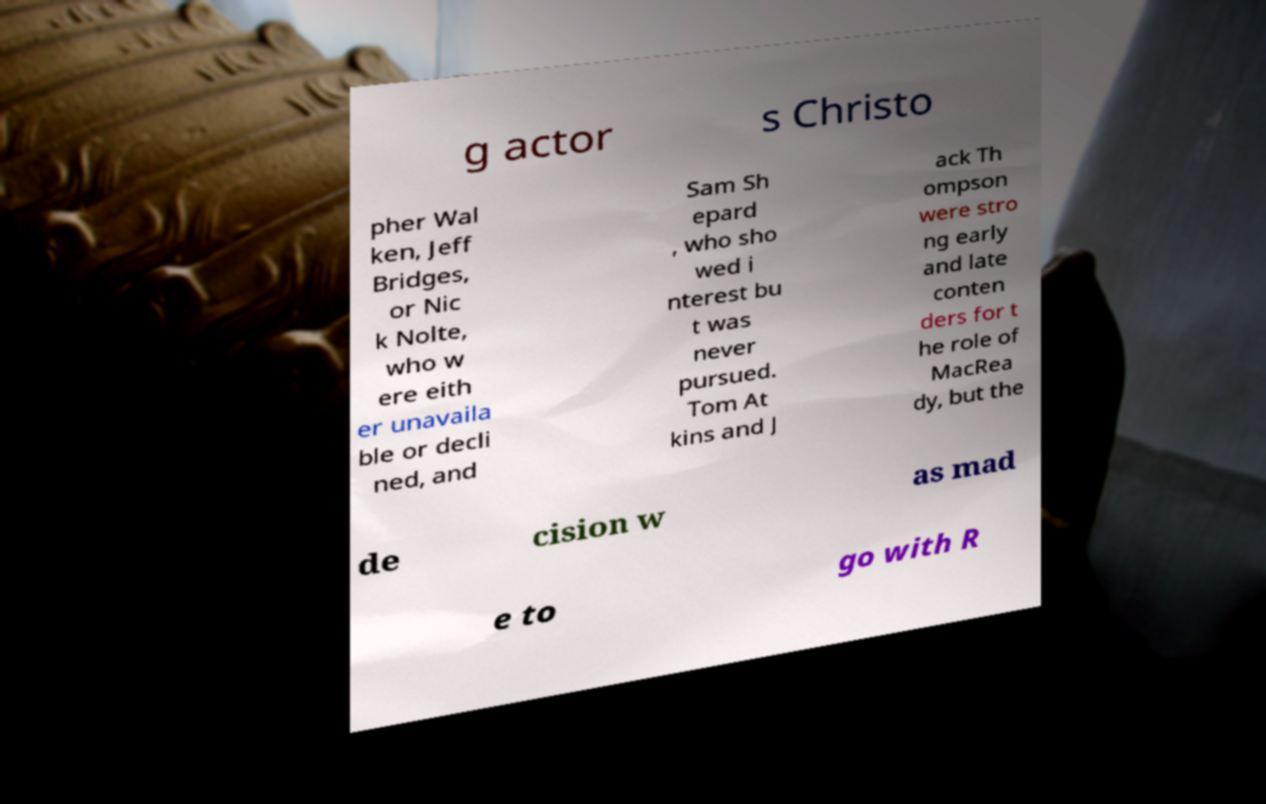Can you read and provide the text displayed in the image?This photo seems to have some interesting text. Can you extract and type it out for me? g actor s Christo pher Wal ken, Jeff Bridges, or Nic k Nolte, who w ere eith er unavaila ble or decli ned, and Sam Sh epard , who sho wed i nterest bu t was never pursued. Tom At kins and J ack Th ompson were stro ng early and late conten ders for t he role of MacRea dy, but the de cision w as mad e to go with R 